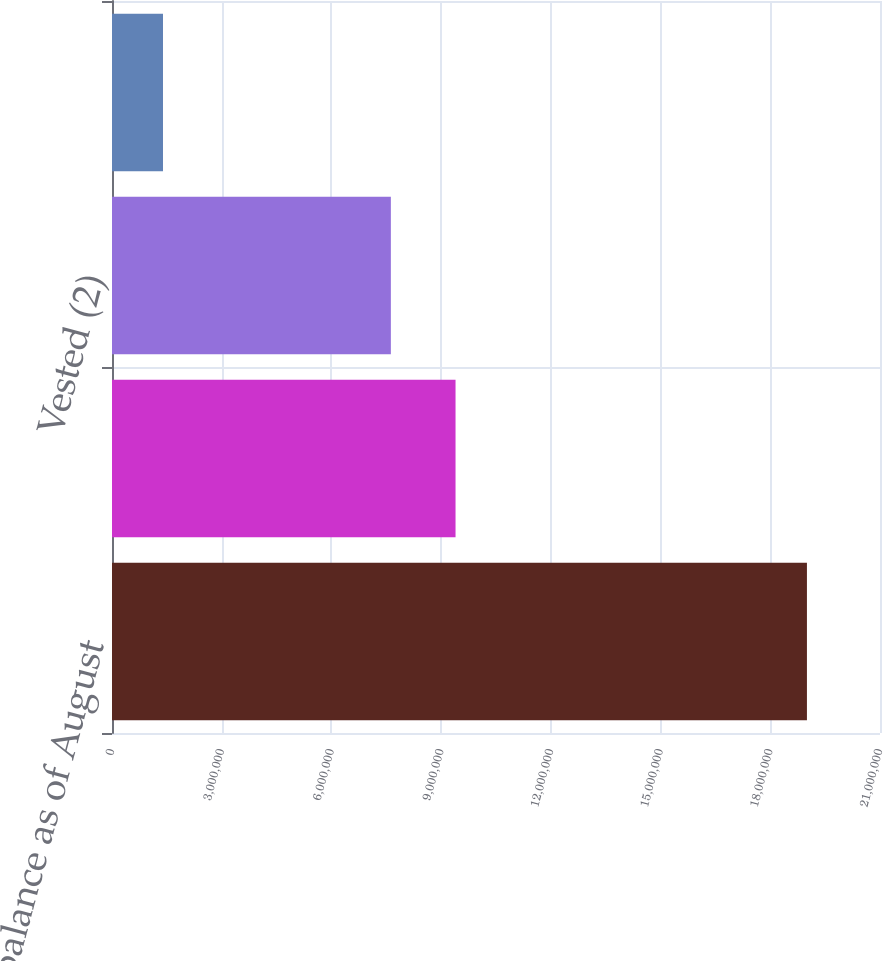Convert chart. <chart><loc_0><loc_0><loc_500><loc_500><bar_chart><fcel>Nonvested balance as of August<fcel>Granted (1)<fcel>Vested (2)<fcel>Forfeited<nl><fcel>1.90021e+07<fcel>9.39355e+06<fcel>7.62512e+06<fcel>1.39432e+06<nl></chart> 